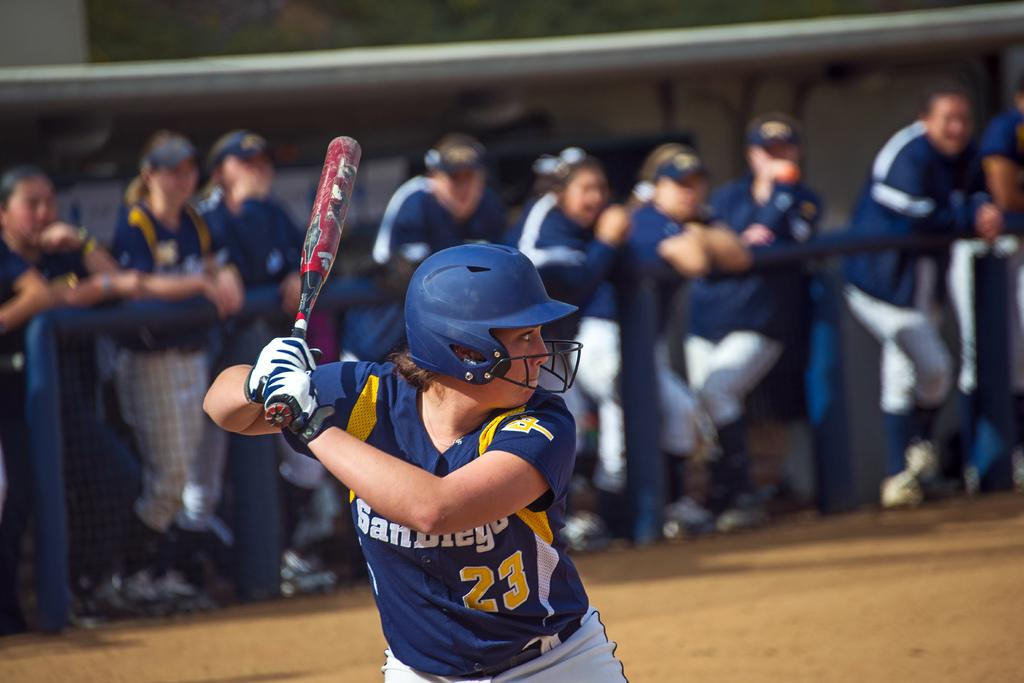<image>
Give a short and clear explanation of the subsequent image. The player San Diego number 23 is up to bat. 